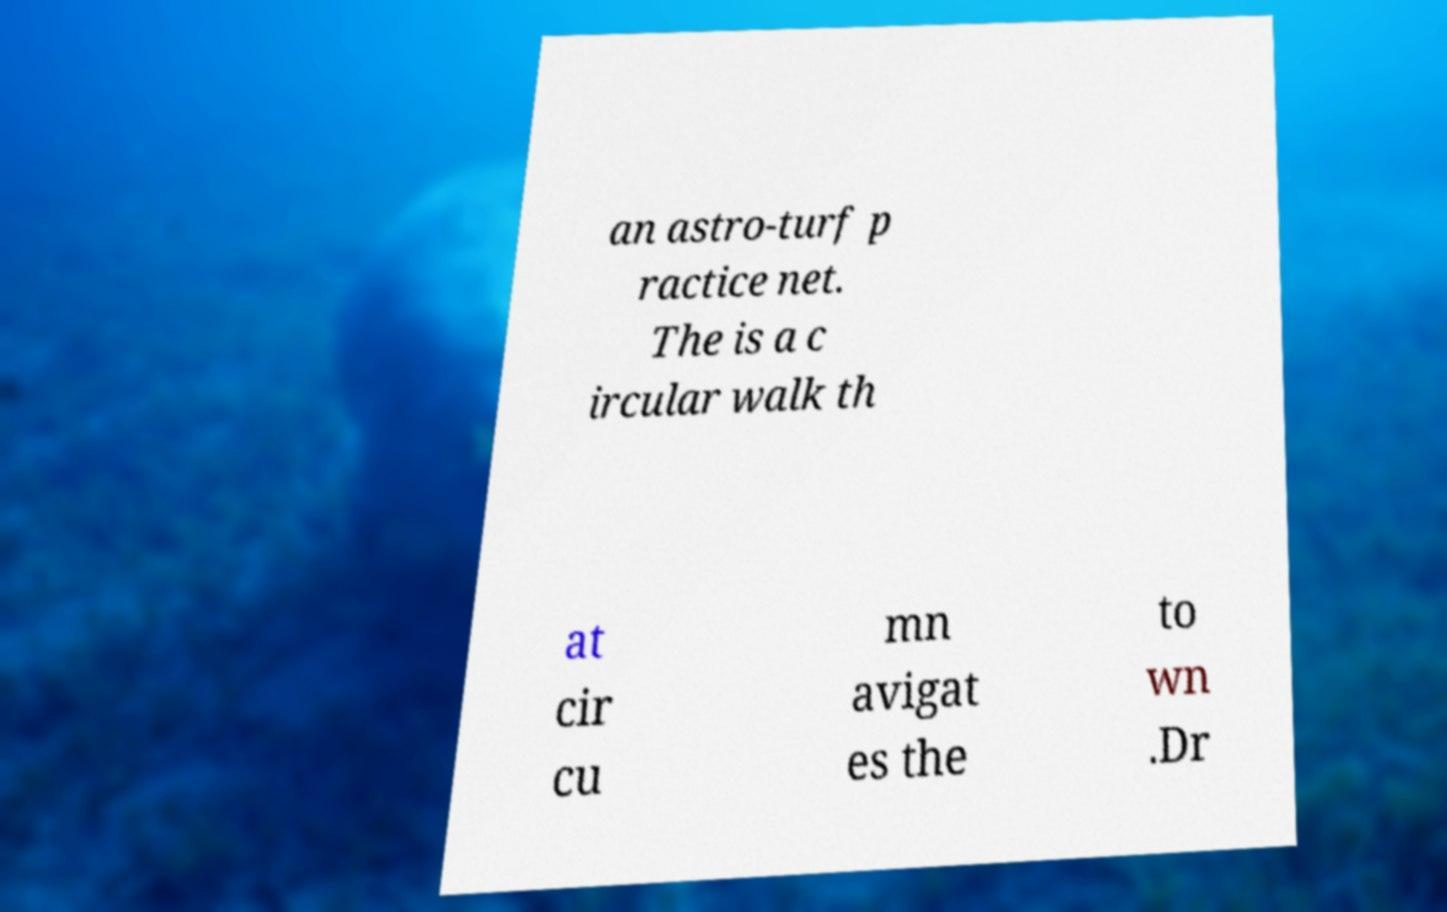I need the written content from this picture converted into text. Can you do that? an astro-turf p ractice net. The is a c ircular walk th at cir cu mn avigat es the to wn .Dr 